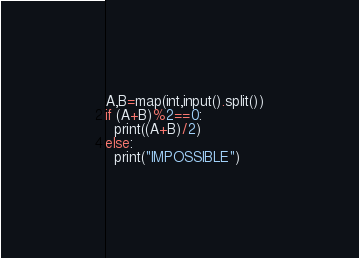Convert code to text. <code><loc_0><loc_0><loc_500><loc_500><_Python_>A,B=map(int,input().split())
if (A+B)%2==0:
  print((A+B)/2)
else:
  print("IMPOSSIBLE")</code> 